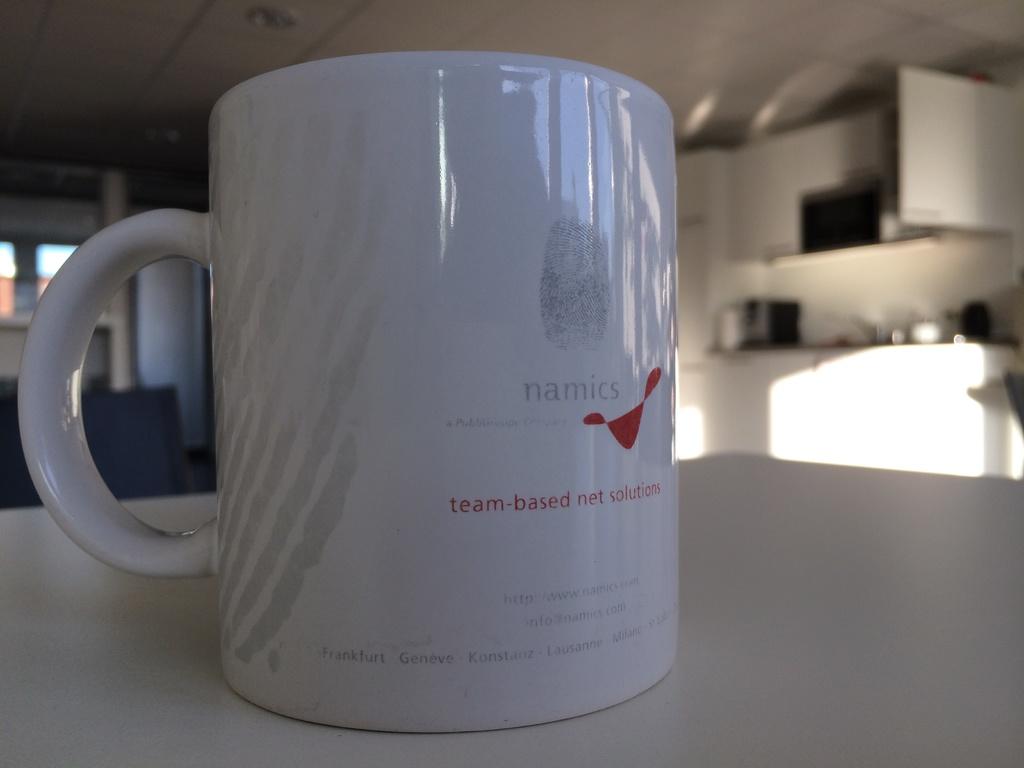What is the brand of the cup?
Provide a short and direct response. Namics. What is written in red in the middle of the mug?
Provide a short and direct response. Team-based net solutions. 